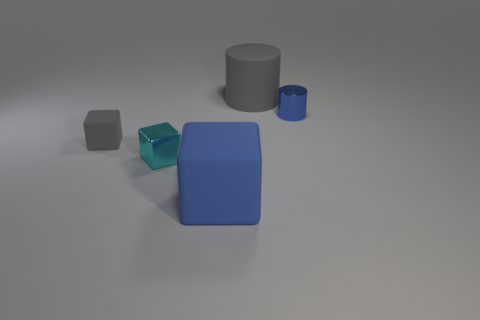Subtract all big blue blocks. How many blocks are left? 2 Add 4 big gray rubber things. How many objects exist? 9 Subtract all purple blocks. Subtract all cyan balls. How many blocks are left? 3 Subtract all blocks. How many objects are left? 2 Add 4 metal blocks. How many metal blocks exist? 5 Subtract 0 brown spheres. How many objects are left? 5 Subtract all large gray things. Subtract all gray rubber cylinders. How many objects are left? 3 Add 2 blue metallic objects. How many blue metallic objects are left? 3 